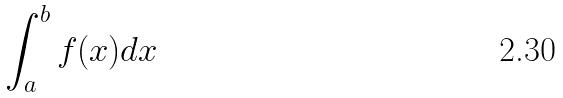Convert formula to latex. <formula><loc_0><loc_0><loc_500><loc_500>\int _ { a } ^ { b } f ( x ) d x</formula> 